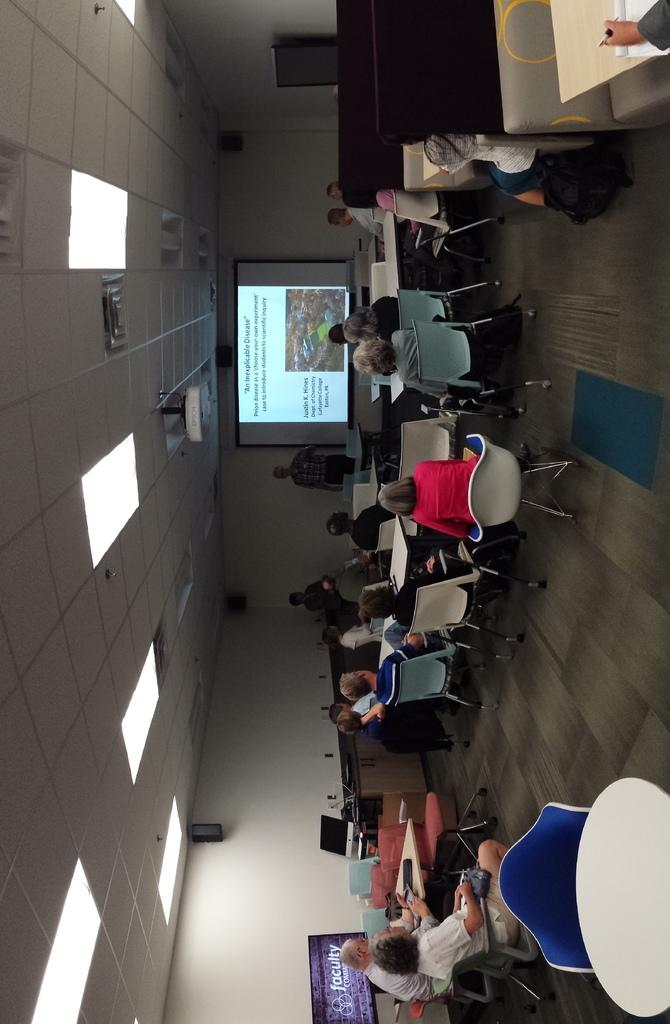<image>
Relay a brief, clear account of the picture shown. A sideways shot of people watching a screen which has the heading 'An inexplicable disease' 